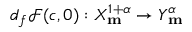<formula> <loc_0><loc_0><loc_500><loc_500>d _ { f } \ m a t h s c r { F } ( c , 0 ) \colon X _ { m } ^ { 1 + \alpha } \rightarrow Y _ { m } ^ { \alpha }</formula> 